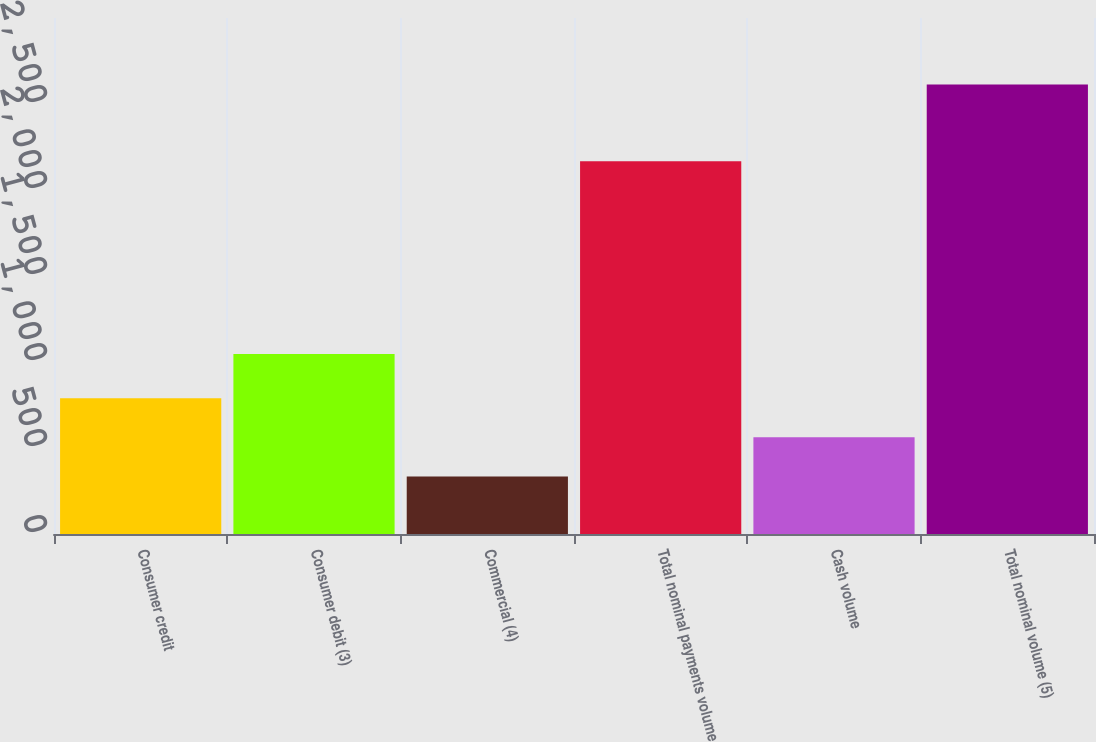<chart> <loc_0><loc_0><loc_500><loc_500><bar_chart><fcel>Consumer credit<fcel>Consumer debit (3)<fcel>Commercial (4)<fcel>Total nominal payments volume<fcel>Cash volume<fcel>Total nominal volume (5)<nl><fcel>789.8<fcel>1046<fcel>334<fcel>2167<fcel>561.9<fcel>2613<nl></chart> 